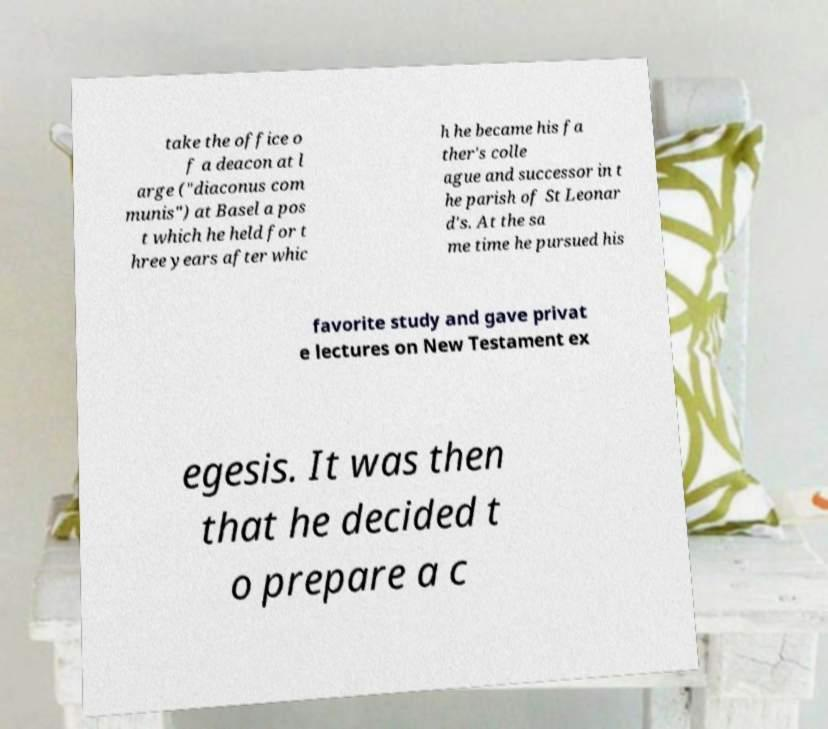For documentation purposes, I need the text within this image transcribed. Could you provide that? take the office o f a deacon at l arge ("diaconus com munis") at Basel a pos t which he held for t hree years after whic h he became his fa ther's colle ague and successor in t he parish of St Leonar d's. At the sa me time he pursued his favorite study and gave privat e lectures on New Testament ex egesis. It was then that he decided t o prepare a c 